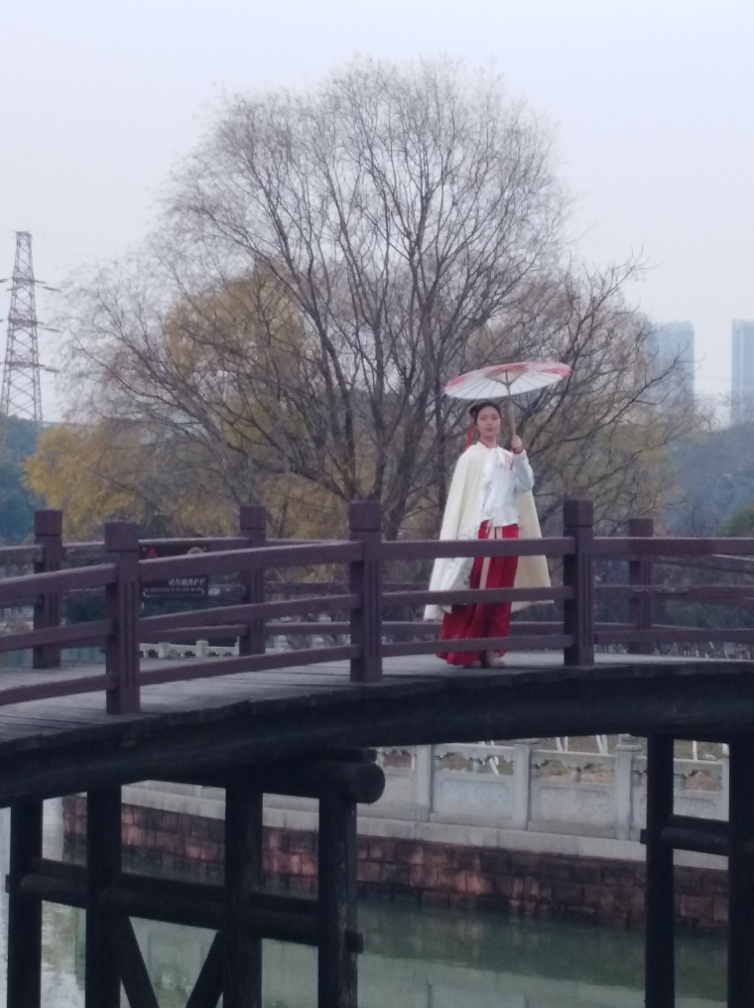Can you describe the atmosphere of this location and how it might be typically used? The atmosphere seems serene and tranquil, with the quiet waters and the solitary figure evoking a sense of calm. Such bridges are often found in parks or historical sites and are typically used for leisurely strolls, providing visitors with picturesque views and a moment of respite from the hustle and bustle of daily life. What details in the image indicate the level of maintenance of this bridge? The bridge appears to be well-maintained, as there are no obvious signs of damage or neglect. The wood shows signs of weathering, which is natural over time, but the structure seems intact with no broken parts or missing planks. Regular maintenance likely includes inspections and preservation treatments to protect the wood from the elements. 